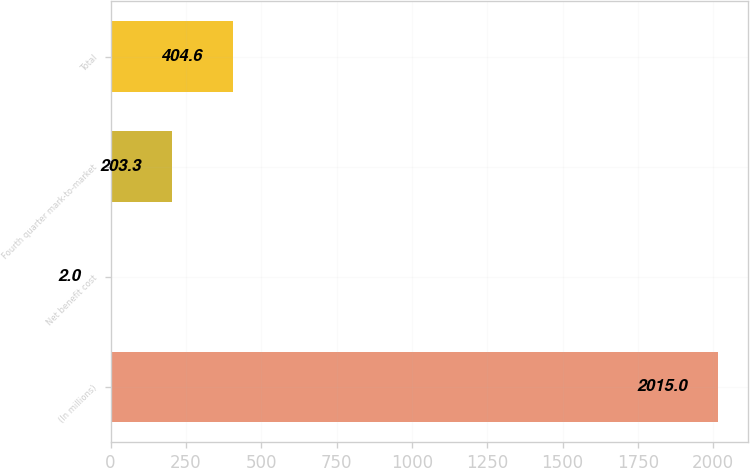<chart> <loc_0><loc_0><loc_500><loc_500><bar_chart><fcel>(In millions)<fcel>Net benefit cost<fcel>Fourth quarter mark-to-market<fcel>Total<nl><fcel>2015<fcel>2<fcel>203.3<fcel>404.6<nl></chart> 